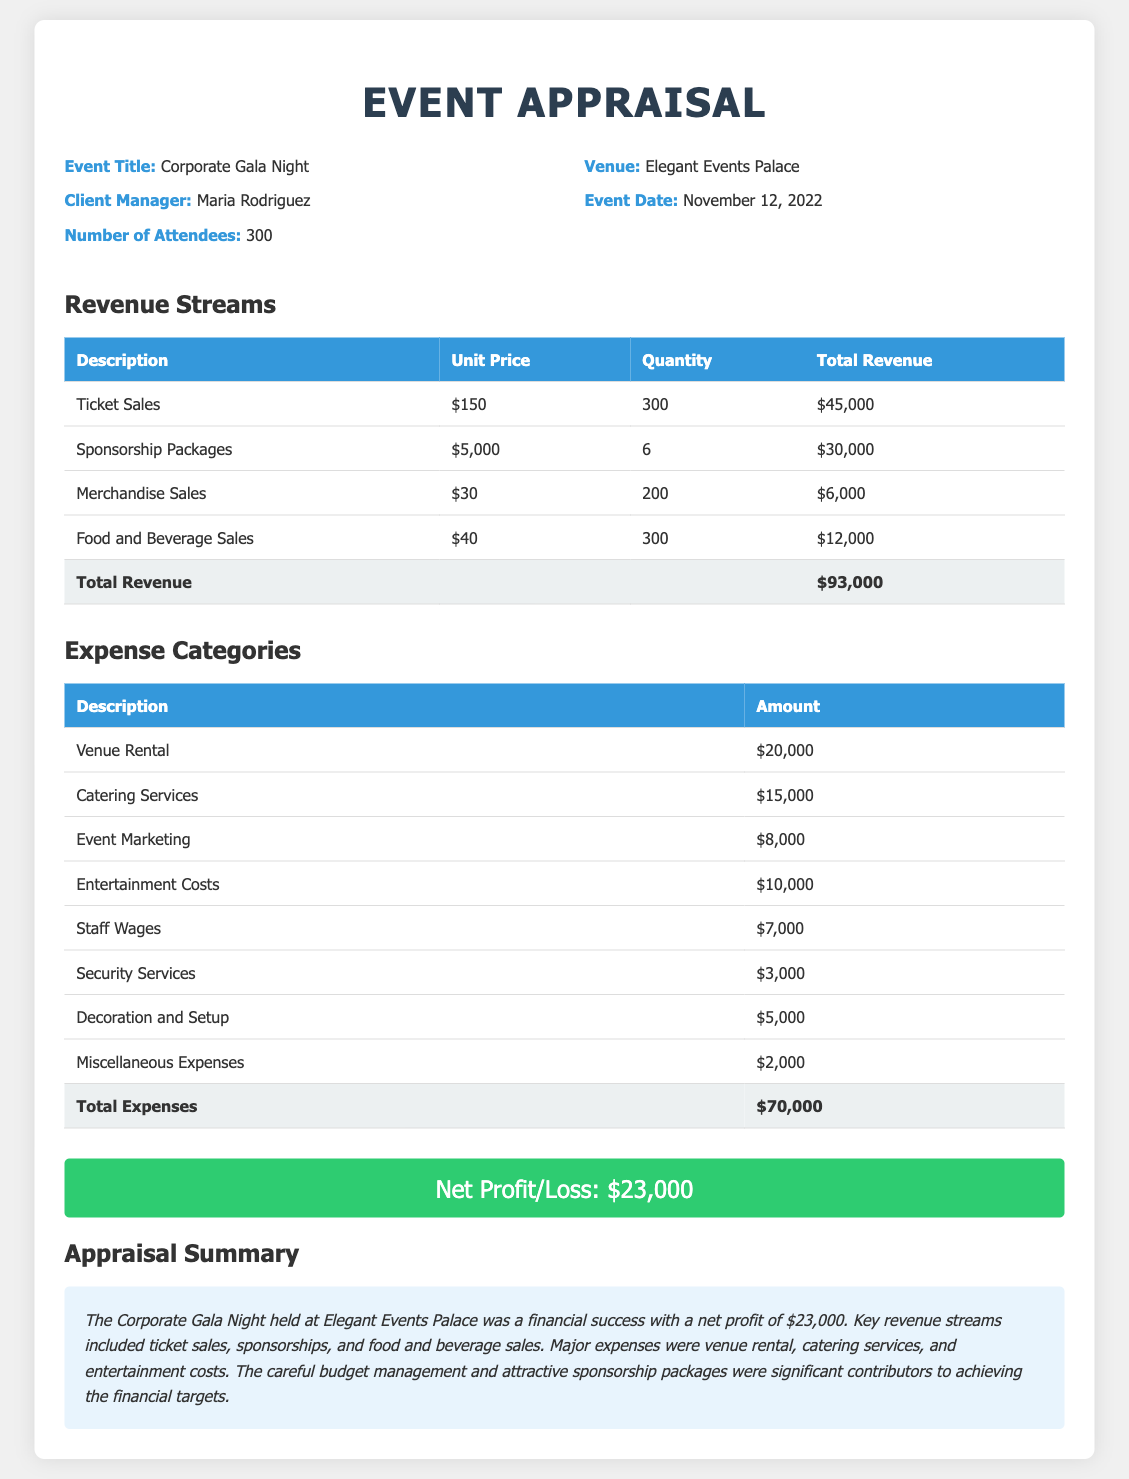what is the event title? The event title is clearly stated in the document under the Event Appraisal section.
Answer: Corporate Gala Night who is the client manager? The client manager's name is provided under the event details in the document.
Answer: Maria Rodriguez what was the event date? The document specifies the date on which the event took place.
Answer: November 12, 2022 what is the total revenue? The total revenue is calculated by summing all the revenue streams listed in the Revenue Streams table.
Answer: $93,000 what is the total expenses? The total expenses are presented in the Expenses Categories table as the cumulative amount of all listed expenses.
Answer: $70,000 what is the net profit? The net profit or loss is clearly stated in the profit-loss section of the document.
Answer: $23,000 which revenue stream generated the most income? The revenue streams table shows which category contributed the highest total revenue from the listed items.
Answer: Ticket Sales what was the largest expense category? The document lists expense categories, and the largest one indicates where the highest amount was spent.
Answer: Venue Rental how many attendees were there? The number of attendees is mentioned in the event details section of the document.
Answer: 300 